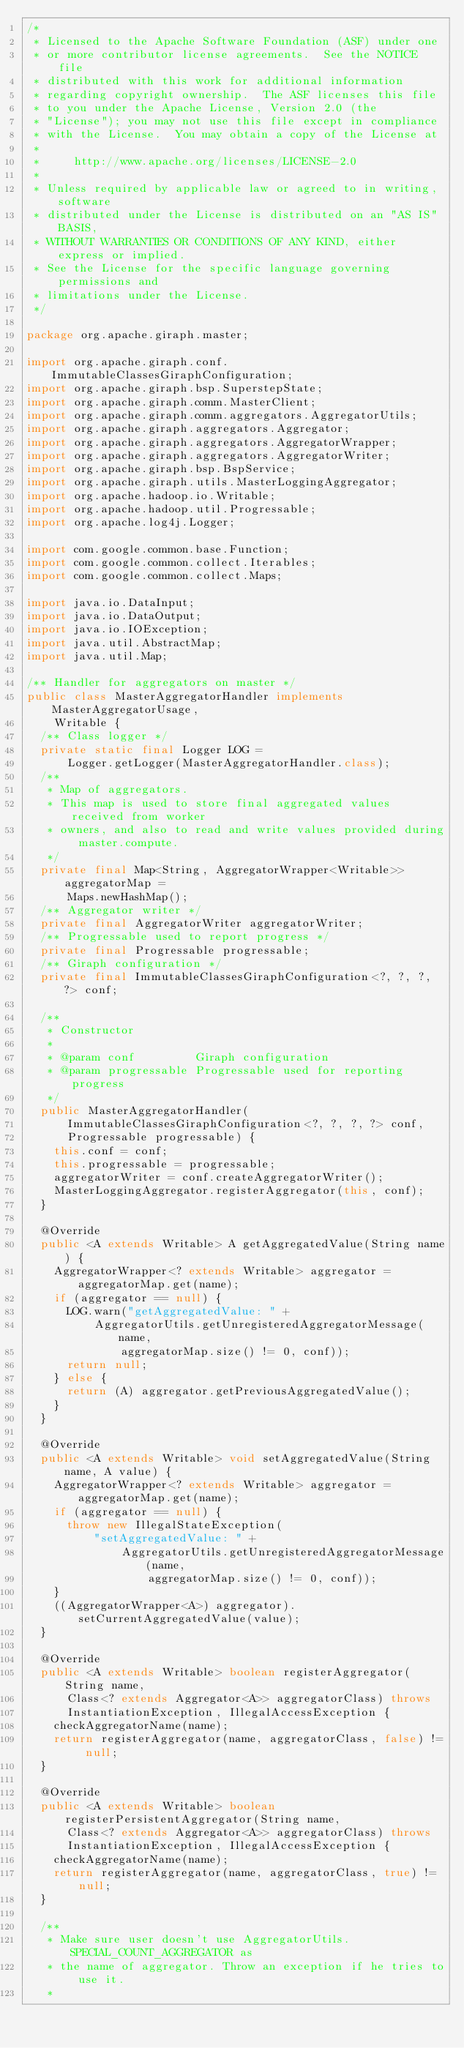<code> <loc_0><loc_0><loc_500><loc_500><_Java_>/*
 * Licensed to the Apache Software Foundation (ASF) under one
 * or more contributor license agreements.  See the NOTICE file
 * distributed with this work for additional information
 * regarding copyright ownership.  The ASF licenses this file
 * to you under the Apache License, Version 2.0 (the
 * "License"); you may not use this file except in compliance
 * with the License.  You may obtain a copy of the License at
 *
 *     http://www.apache.org/licenses/LICENSE-2.0
 *
 * Unless required by applicable law or agreed to in writing, software
 * distributed under the License is distributed on an "AS IS" BASIS,
 * WITHOUT WARRANTIES OR CONDITIONS OF ANY KIND, either express or implied.
 * See the License for the specific language governing permissions and
 * limitations under the License.
 */

package org.apache.giraph.master;

import org.apache.giraph.conf.ImmutableClassesGiraphConfiguration;
import org.apache.giraph.bsp.SuperstepState;
import org.apache.giraph.comm.MasterClient;
import org.apache.giraph.comm.aggregators.AggregatorUtils;
import org.apache.giraph.aggregators.Aggregator;
import org.apache.giraph.aggregators.AggregatorWrapper;
import org.apache.giraph.aggregators.AggregatorWriter;
import org.apache.giraph.bsp.BspService;
import org.apache.giraph.utils.MasterLoggingAggregator;
import org.apache.hadoop.io.Writable;
import org.apache.hadoop.util.Progressable;
import org.apache.log4j.Logger;

import com.google.common.base.Function;
import com.google.common.collect.Iterables;
import com.google.common.collect.Maps;

import java.io.DataInput;
import java.io.DataOutput;
import java.io.IOException;
import java.util.AbstractMap;
import java.util.Map;

/** Handler for aggregators on master */
public class MasterAggregatorHandler implements MasterAggregatorUsage,
    Writable {
  /** Class logger */
  private static final Logger LOG =
      Logger.getLogger(MasterAggregatorHandler.class);
  /**
   * Map of aggregators.
   * This map is used to store final aggregated values received from worker
   * owners, and also to read and write values provided during master.compute.
   */
  private final Map<String, AggregatorWrapper<Writable>> aggregatorMap =
      Maps.newHashMap();
  /** Aggregator writer */
  private final AggregatorWriter aggregatorWriter;
  /** Progressable used to report progress */
  private final Progressable progressable;
  /** Giraph configuration */
  private final ImmutableClassesGiraphConfiguration<?, ?, ?, ?> conf;

  /**
   * Constructor
   *
   * @param conf         Giraph configuration
   * @param progressable Progressable used for reporting progress
   */
  public MasterAggregatorHandler(
      ImmutableClassesGiraphConfiguration<?, ?, ?, ?> conf,
      Progressable progressable) {
    this.conf = conf;
    this.progressable = progressable;
    aggregatorWriter = conf.createAggregatorWriter();
    MasterLoggingAggregator.registerAggregator(this, conf);
  }

  @Override
  public <A extends Writable> A getAggregatedValue(String name) {
    AggregatorWrapper<? extends Writable> aggregator = aggregatorMap.get(name);
    if (aggregator == null) {
      LOG.warn("getAggregatedValue: " +
          AggregatorUtils.getUnregisteredAggregatorMessage(name,
              aggregatorMap.size() != 0, conf));
      return null;
    } else {
      return (A) aggregator.getPreviousAggregatedValue();
    }
  }

  @Override
  public <A extends Writable> void setAggregatedValue(String name, A value) {
    AggregatorWrapper<? extends Writable> aggregator = aggregatorMap.get(name);
    if (aggregator == null) {
      throw new IllegalStateException(
          "setAggregatedValue: " +
              AggregatorUtils.getUnregisteredAggregatorMessage(name,
                  aggregatorMap.size() != 0, conf));
    }
    ((AggregatorWrapper<A>) aggregator).setCurrentAggregatedValue(value);
  }

  @Override
  public <A extends Writable> boolean registerAggregator(String name,
      Class<? extends Aggregator<A>> aggregatorClass) throws
      InstantiationException, IllegalAccessException {
    checkAggregatorName(name);
    return registerAggregator(name, aggregatorClass, false) != null;
  }

  @Override
  public <A extends Writable> boolean registerPersistentAggregator(String name,
      Class<? extends Aggregator<A>> aggregatorClass) throws
      InstantiationException, IllegalAccessException {
    checkAggregatorName(name);
    return registerAggregator(name, aggregatorClass, true) != null;
  }

  /**
   * Make sure user doesn't use AggregatorUtils.SPECIAL_COUNT_AGGREGATOR as
   * the name of aggregator. Throw an exception if he tries to use it.
   *</code> 